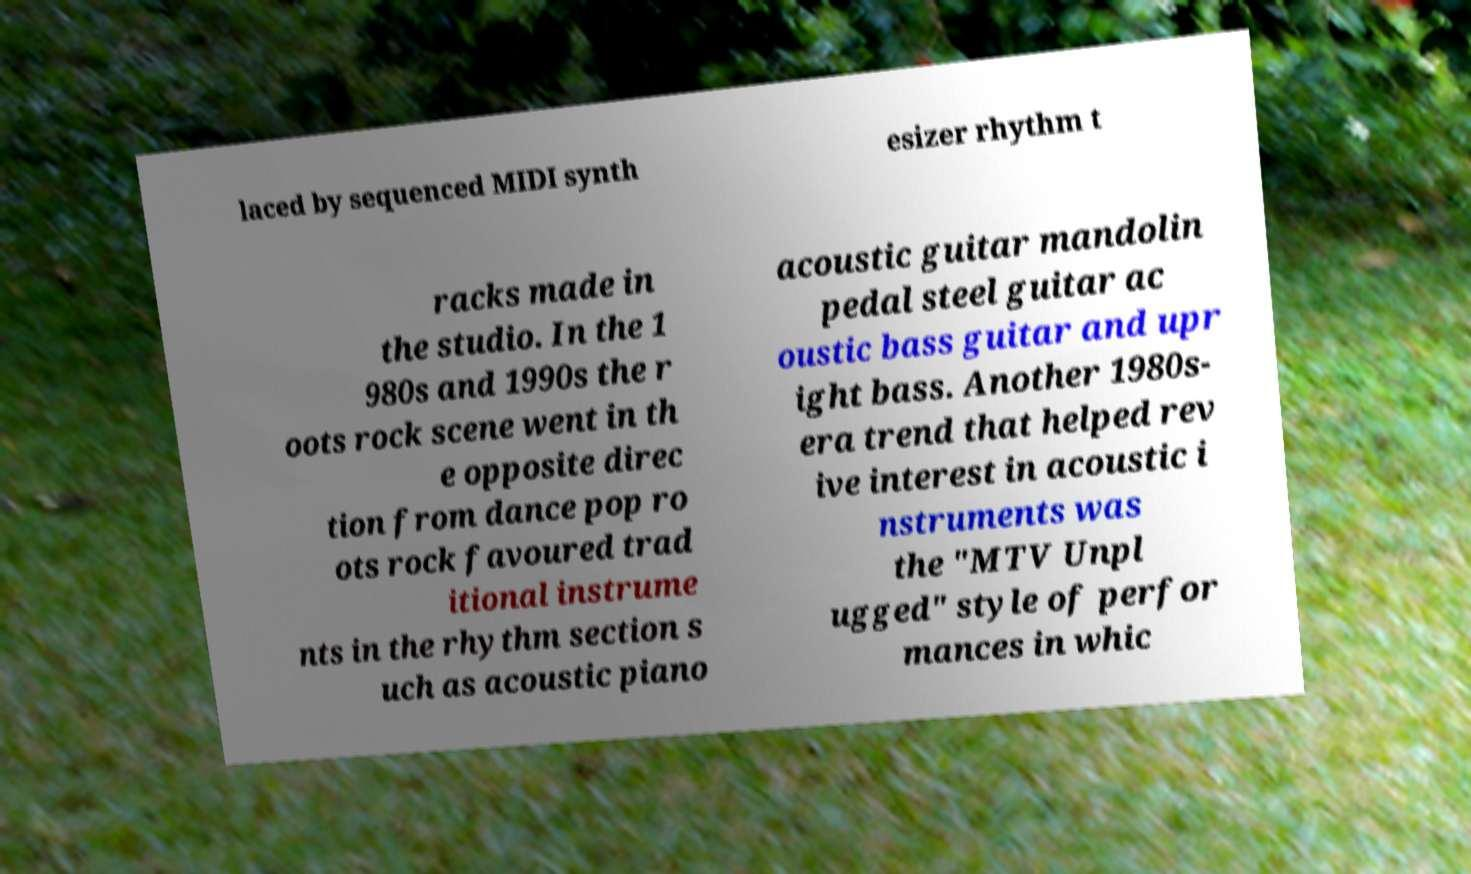What messages or text are displayed in this image? I need them in a readable, typed format. laced by sequenced MIDI synth esizer rhythm t racks made in the studio. In the 1 980s and 1990s the r oots rock scene went in th e opposite direc tion from dance pop ro ots rock favoured trad itional instrume nts in the rhythm section s uch as acoustic piano acoustic guitar mandolin pedal steel guitar ac oustic bass guitar and upr ight bass. Another 1980s- era trend that helped rev ive interest in acoustic i nstruments was the "MTV Unpl ugged" style of perfor mances in whic 